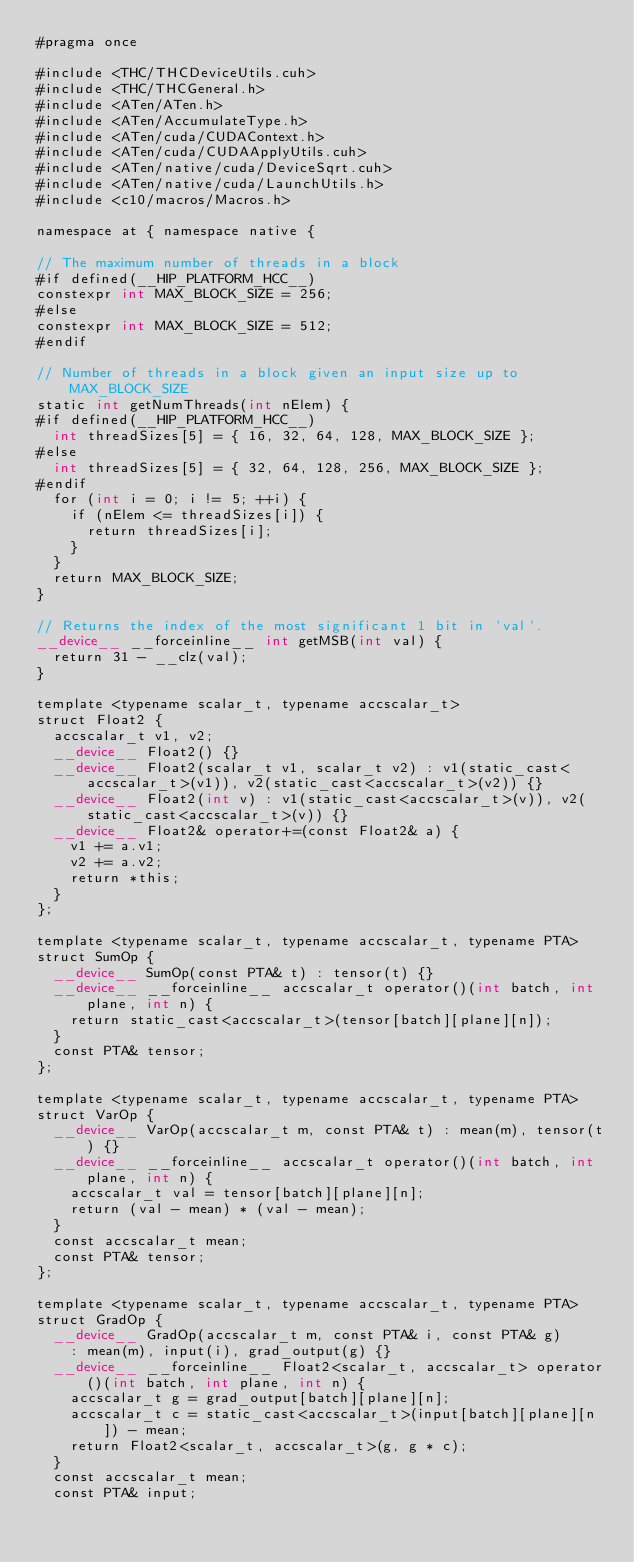<code> <loc_0><loc_0><loc_500><loc_500><_Cuda_>#pragma once

#include <THC/THCDeviceUtils.cuh>
#include <THC/THCGeneral.h>
#include <ATen/ATen.h>
#include <ATen/AccumulateType.h>
#include <ATen/cuda/CUDAContext.h>
#include <ATen/cuda/CUDAApplyUtils.cuh>
#include <ATen/native/cuda/DeviceSqrt.cuh>
#include <ATen/native/cuda/LaunchUtils.h>
#include <c10/macros/Macros.h>

namespace at { namespace native {

// The maximum number of threads in a block
#if defined(__HIP_PLATFORM_HCC__)
constexpr int MAX_BLOCK_SIZE = 256;
#else
constexpr int MAX_BLOCK_SIZE = 512;
#endif

// Number of threads in a block given an input size up to MAX_BLOCK_SIZE
static int getNumThreads(int nElem) {
#if defined(__HIP_PLATFORM_HCC__)
  int threadSizes[5] = { 16, 32, 64, 128, MAX_BLOCK_SIZE };
#else
  int threadSizes[5] = { 32, 64, 128, 256, MAX_BLOCK_SIZE };
#endif
  for (int i = 0; i != 5; ++i) {
    if (nElem <= threadSizes[i]) {
      return threadSizes[i];
    }
  }
  return MAX_BLOCK_SIZE;
}

// Returns the index of the most significant 1 bit in `val`.
__device__ __forceinline__ int getMSB(int val) {
  return 31 - __clz(val);
}

template <typename scalar_t, typename accscalar_t>
struct Float2 {
  accscalar_t v1, v2;
  __device__ Float2() {}
  __device__ Float2(scalar_t v1, scalar_t v2) : v1(static_cast<accscalar_t>(v1)), v2(static_cast<accscalar_t>(v2)) {}
  __device__ Float2(int v) : v1(static_cast<accscalar_t>(v)), v2(static_cast<accscalar_t>(v)) {}
  __device__ Float2& operator+=(const Float2& a) {
    v1 += a.v1;
    v2 += a.v2;
    return *this;
  }
};

template <typename scalar_t, typename accscalar_t, typename PTA>
struct SumOp {
  __device__ SumOp(const PTA& t) : tensor(t) {}
  __device__ __forceinline__ accscalar_t operator()(int batch, int plane, int n) {
    return static_cast<accscalar_t>(tensor[batch][plane][n]);
  }
  const PTA& tensor;
};

template <typename scalar_t, typename accscalar_t, typename PTA>
struct VarOp {
  __device__ VarOp(accscalar_t m, const PTA& t) : mean(m), tensor(t) {}
  __device__ __forceinline__ accscalar_t operator()(int batch, int plane, int n) {
    accscalar_t val = tensor[batch][plane][n];
    return (val - mean) * (val - mean);
  }
  const accscalar_t mean;
  const PTA& tensor;
};

template <typename scalar_t, typename accscalar_t, typename PTA>
struct GradOp {
  __device__ GradOp(accscalar_t m, const PTA& i, const PTA& g)
    : mean(m), input(i), grad_output(g) {}
  __device__ __forceinline__ Float2<scalar_t, accscalar_t> operator()(int batch, int plane, int n) {
    accscalar_t g = grad_output[batch][plane][n];
    accscalar_t c = static_cast<accscalar_t>(input[batch][plane][n]) - mean;
    return Float2<scalar_t, accscalar_t>(g, g * c);
  }
  const accscalar_t mean;
  const PTA& input;</code> 